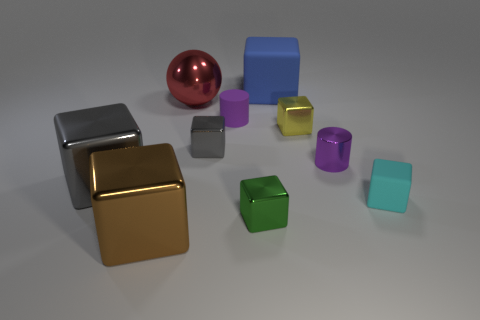Subtract all metallic cubes. How many cubes are left? 2 Subtract 2 cubes. How many cubes are left? 5 Subtract all blue balls. How many gray cubes are left? 2 Subtract all green cubes. How many cubes are left? 6 Subtract all yellow blocks. Subtract all green cylinders. How many blocks are left? 6 Subtract 0 green spheres. How many objects are left? 10 Subtract all cylinders. How many objects are left? 8 Subtract all brown balls. Subtract all small cyan cubes. How many objects are left? 9 Add 3 yellow metal things. How many yellow metal things are left? 4 Add 4 cyan matte cubes. How many cyan matte cubes exist? 5 